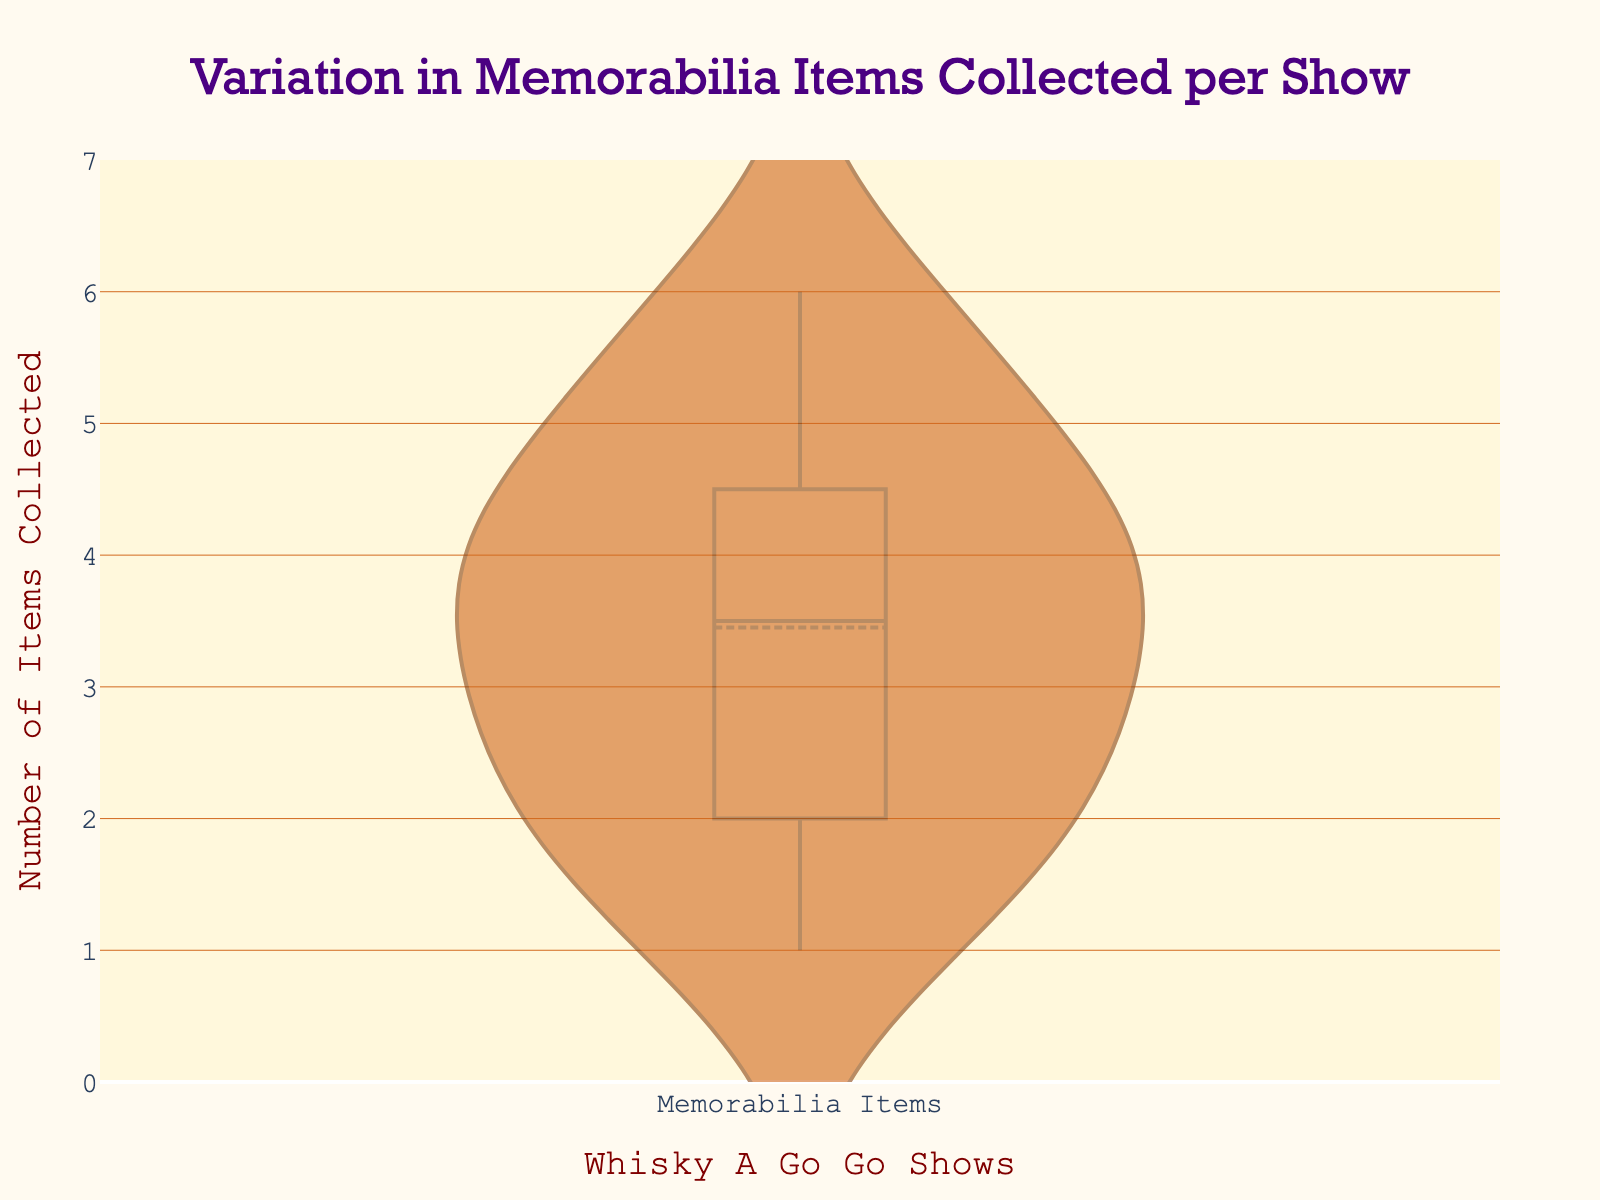What's the title of the figure? The title is usually located at the top of the figure and is written in larger font size. In this case, it indicates the subject of the plot.
Answer: Variation in Memorabilia Items Collected per Show What is the range of the y-axis? The y-axis usually depicts the quantity in the plot, and the range can be determined by observing the minimum and maximum values indicated.
Answer: 0 to 7 How many items were most commonly collected per show? By looking at the violin plot, we see where the plot is widest, indicating the most frequent value.
Answer: 4 What's the median number of memorabilia items collected per show? The median is the line inside the box of the violin plot, showing the middle value once the data is ordered.
Answer: 4 What is the interquartile range (IQR) of memorabilia items collected? The IQR is the range of the box in the violin plot, indicating the spread between the first and third quartiles.
Answer: 2 Which show has the maximum number of memorabilia items collected? Compare the individual data points within the violin plot to find the highest value.
Answer: Mötley Crüe - 1981 and Nirvana - 1991 (both 6 items) What color is used to fill the violin plot? The color used in the violin plot is indicated by the fill inside the violin and is described in natural terms.
Answer: Orange-brown What is the mean number of memorabilia items collected per show? The mean is represented by the line in the violin plot itself, which shows where the average value lies.
Answer: Meanline visible at 3.45 Which shows had the least number of memorabilia items collected? The data points at the lowest part of the violin plot will indicate the shows with the fewest items collected.
Answer: The Byrds - 1966 and Buffalo Springfield - 1967 (1 item each) How does the number of items collected for "Van Halen - 1977" compare to "KISS - 1973"? Locate and compare the data points for these two shows within the plot.
Answer: Van Halen - 1977 has 1 more item (5 vs. 4) 